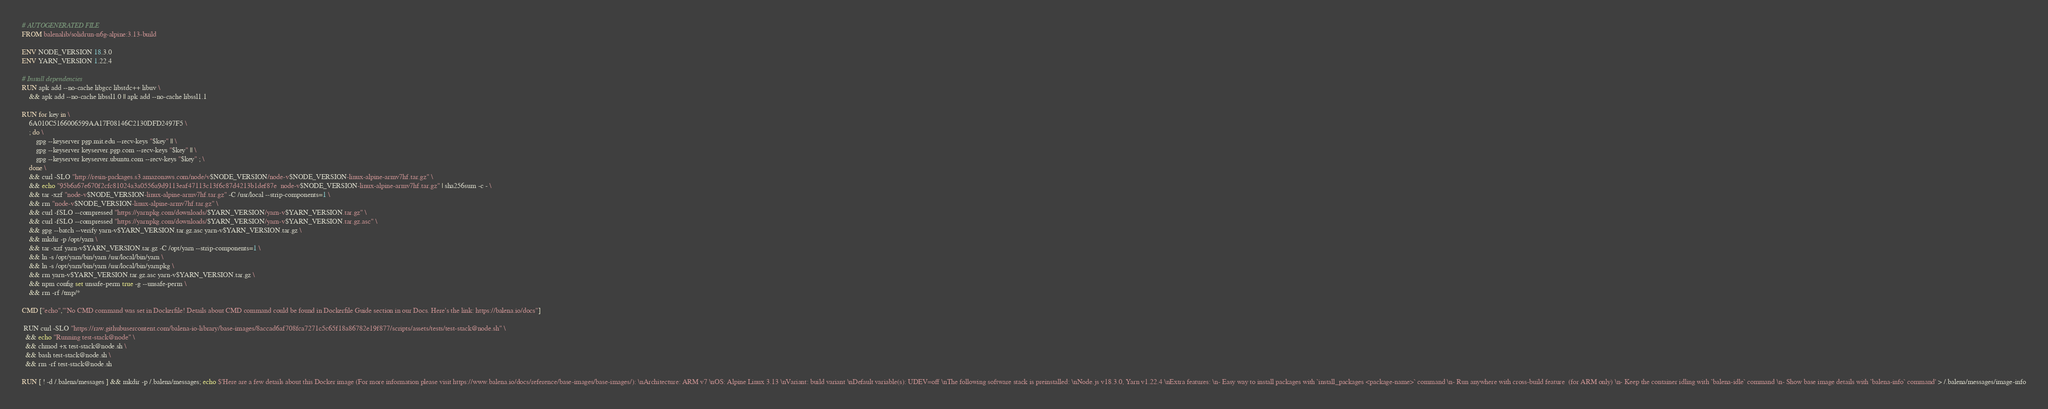Convert code to text. <code><loc_0><loc_0><loc_500><loc_500><_Dockerfile_># AUTOGENERATED FILE
FROM balenalib/solidrun-n6g-alpine:3.13-build

ENV NODE_VERSION 18.3.0
ENV YARN_VERSION 1.22.4

# Install dependencies
RUN apk add --no-cache libgcc libstdc++ libuv \
	&& apk add --no-cache libssl1.0 || apk add --no-cache libssl1.1

RUN for key in \
	6A010C5166006599AA17F08146C2130DFD2497F5 \
	; do \
		gpg --keyserver pgp.mit.edu --recv-keys "$key" || \
		gpg --keyserver keyserver.pgp.com --recv-keys "$key" || \
		gpg --keyserver keyserver.ubuntu.com --recv-keys "$key" ; \
	done \
	&& curl -SLO "http://resin-packages.s3.amazonaws.com/node/v$NODE_VERSION/node-v$NODE_VERSION-linux-alpine-armv7hf.tar.gz" \
	&& echo "95b6a67e670f2cfc81024a3a0556a9d9113eaf47113c13f6c87d4213b1def87e  node-v$NODE_VERSION-linux-alpine-armv7hf.tar.gz" | sha256sum -c - \
	&& tar -xzf "node-v$NODE_VERSION-linux-alpine-armv7hf.tar.gz" -C /usr/local --strip-components=1 \
	&& rm "node-v$NODE_VERSION-linux-alpine-armv7hf.tar.gz" \
	&& curl -fSLO --compressed "https://yarnpkg.com/downloads/$YARN_VERSION/yarn-v$YARN_VERSION.tar.gz" \
	&& curl -fSLO --compressed "https://yarnpkg.com/downloads/$YARN_VERSION/yarn-v$YARN_VERSION.tar.gz.asc" \
	&& gpg --batch --verify yarn-v$YARN_VERSION.tar.gz.asc yarn-v$YARN_VERSION.tar.gz \
	&& mkdir -p /opt/yarn \
	&& tar -xzf yarn-v$YARN_VERSION.tar.gz -C /opt/yarn --strip-components=1 \
	&& ln -s /opt/yarn/bin/yarn /usr/local/bin/yarn \
	&& ln -s /opt/yarn/bin/yarn /usr/local/bin/yarnpkg \
	&& rm yarn-v$YARN_VERSION.tar.gz.asc yarn-v$YARN_VERSION.tar.gz \
	&& npm config set unsafe-perm true -g --unsafe-perm \
	&& rm -rf /tmp/*

CMD ["echo","'No CMD command was set in Dockerfile! Details about CMD command could be found in Dockerfile Guide section in our Docs. Here's the link: https://balena.io/docs"]

 RUN curl -SLO "https://raw.githubusercontent.com/balena-io-library/base-images/8accad6af708fca7271c5c65f18a86782e19f877/scripts/assets/tests/test-stack@node.sh" \
  && echo "Running test-stack@node" \
  && chmod +x test-stack@node.sh \
  && bash test-stack@node.sh \
  && rm -rf test-stack@node.sh 

RUN [ ! -d /.balena/messages ] && mkdir -p /.balena/messages; echo $'Here are a few details about this Docker image (For more information please visit https://www.balena.io/docs/reference/base-images/base-images/): \nArchitecture: ARM v7 \nOS: Alpine Linux 3.13 \nVariant: build variant \nDefault variable(s): UDEV=off \nThe following software stack is preinstalled: \nNode.js v18.3.0, Yarn v1.22.4 \nExtra features: \n- Easy way to install packages with `install_packages <package-name>` command \n- Run anywhere with cross-build feature  (for ARM only) \n- Keep the container idling with `balena-idle` command \n- Show base image details with `balena-info` command' > /.balena/messages/image-info</code> 